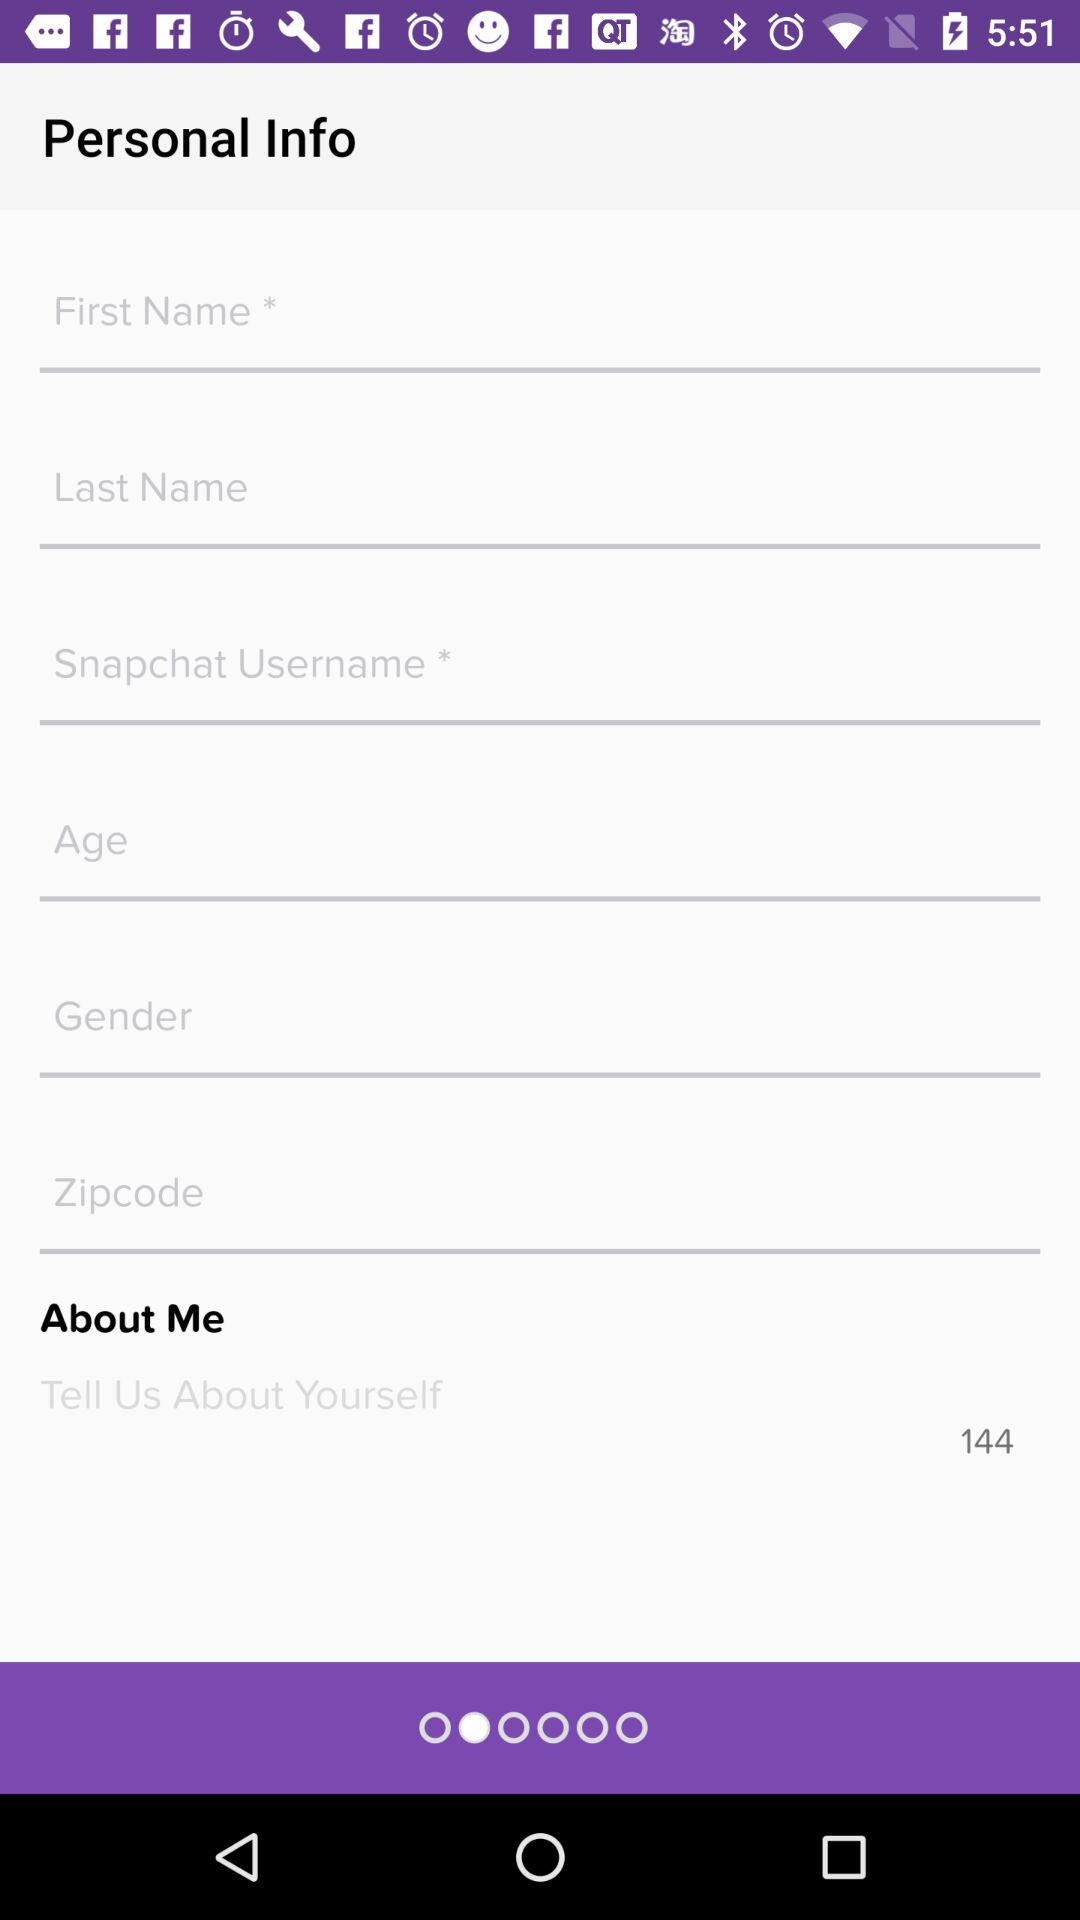How old is the user?
When the provided information is insufficient, respond with <no answer>. <no answer> 